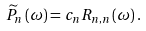<formula> <loc_0><loc_0><loc_500><loc_500>\widetilde { P } _ { n } \left ( \omega \right ) = c _ { n } R _ { n , n } \left ( \omega \right ) .</formula> 